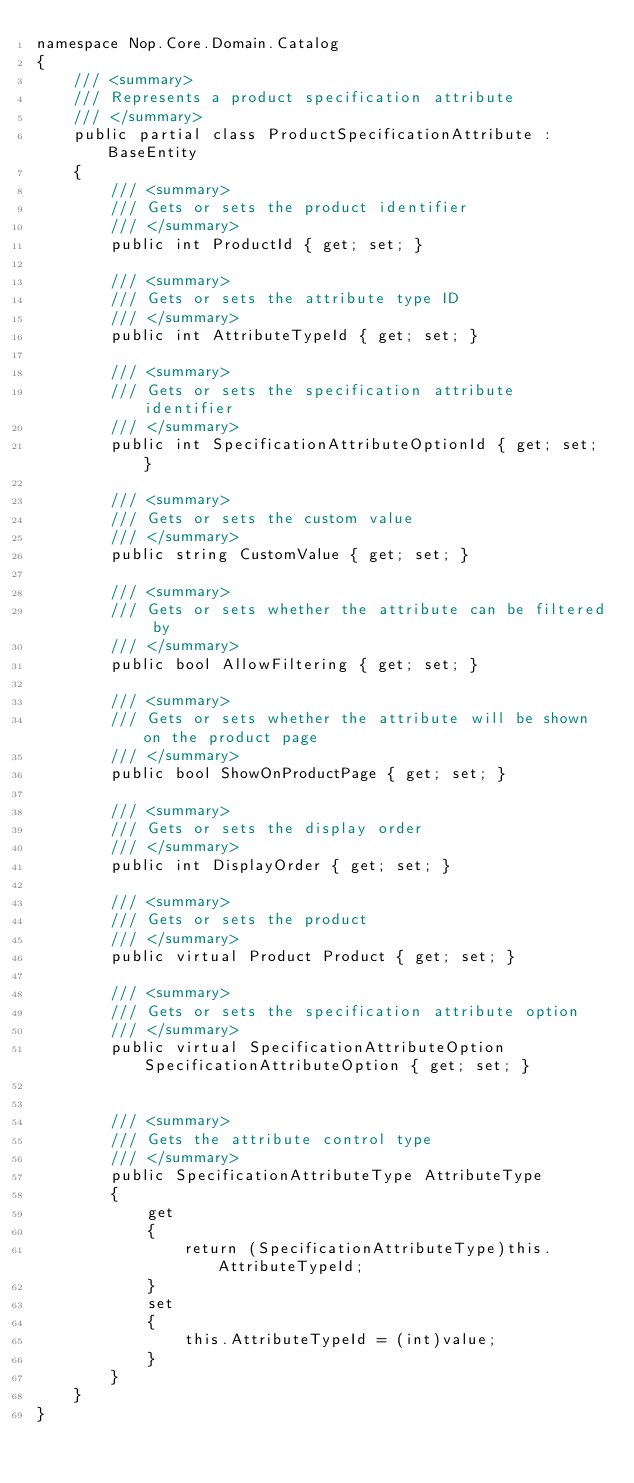<code> <loc_0><loc_0><loc_500><loc_500><_C#_>namespace Nop.Core.Domain.Catalog
{
    /// <summary>
    /// Represents a product specification attribute
    /// </summary>
    public partial class ProductSpecificationAttribute : BaseEntity
    {
        /// <summary>
        /// Gets or sets the product identifier
        /// </summary>
        public int ProductId { get; set; }

        /// <summary>
        /// Gets or sets the attribute type ID
        /// </summary>
        public int AttributeTypeId { get; set; }

        /// <summary>
        /// Gets or sets the specification attribute identifier
        /// </summary>
        public int SpecificationAttributeOptionId { get; set; }

        /// <summary>
        /// Gets or sets the custom value
        /// </summary>
        public string CustomValue { get; set; }

        /// <summary>
        /// Gets or sets whether the attribute can be filtered by
        /// </summary>
        public bool AllowFiltering { get; set; }

        /// <summary>
        /// Gets or sets whether the attribute will be shown on the product page
        /// </summary>
        public bool ShowOnProductPage { get; set; }

        /// <summary>
        /// Gets or sets the display order
        /// </summary>
        public int DisplayOrder { get; set; }
        
        /// <summary>
        /// Gets or sets the product
        /// </summary>
        public virtual Product Product { get; set; }

        /// <summary>
        /// Gets or sets the specification attribute option
        /// </summary>
        public virtual SpecificationAttributeOption SpecificationAttributeOption { get; set; }


        /// <summary>
        /// Gets the attribute control type
        /// </summary>
        public SpecificationAttributeType AttributeType
        {
            get
            {
                return (SpecificationAttributeType)this.AttributeTypeId;
            }
            set
            {
                this.AttributeTypeId = (int)value;
            }
        }
    }
}
</code> 